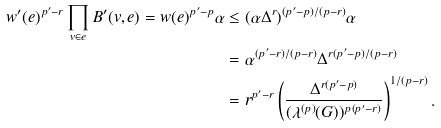<formula> <loc_0><loc_0><loc_500><loc_500>w ^ { \prime } ( e ) ^ { p ^ { \prime } - r } \prod _ { v \in e } B ^ { \prime } ( v , e ) = w ( e ) ^ { p ^ { \prime } - p } \alpha & \leq ( \alpha \Delta ^ { r } ) ^ { ( p ^ { \prime } - p ) / ( p - r ) } \alpha \\ & = \alpha ^ { ( p ^ { \prime } - r ) / ( p - r ) } \Delta ^ { r ( p ^ { \prime } - p ) / ( p - r ) } \\ & = r ^ { p ^ { \prime } - r } \left ( \frac { \Delta ^ { r ( p ^ { \prime } - p ) } } { ( \lambda ^ { ( p ) } ( G ) ) ^ { p ( p ^ { \prime } - r ) } } \right ) ^ { 1 / ( p - r ) } .</formula> 